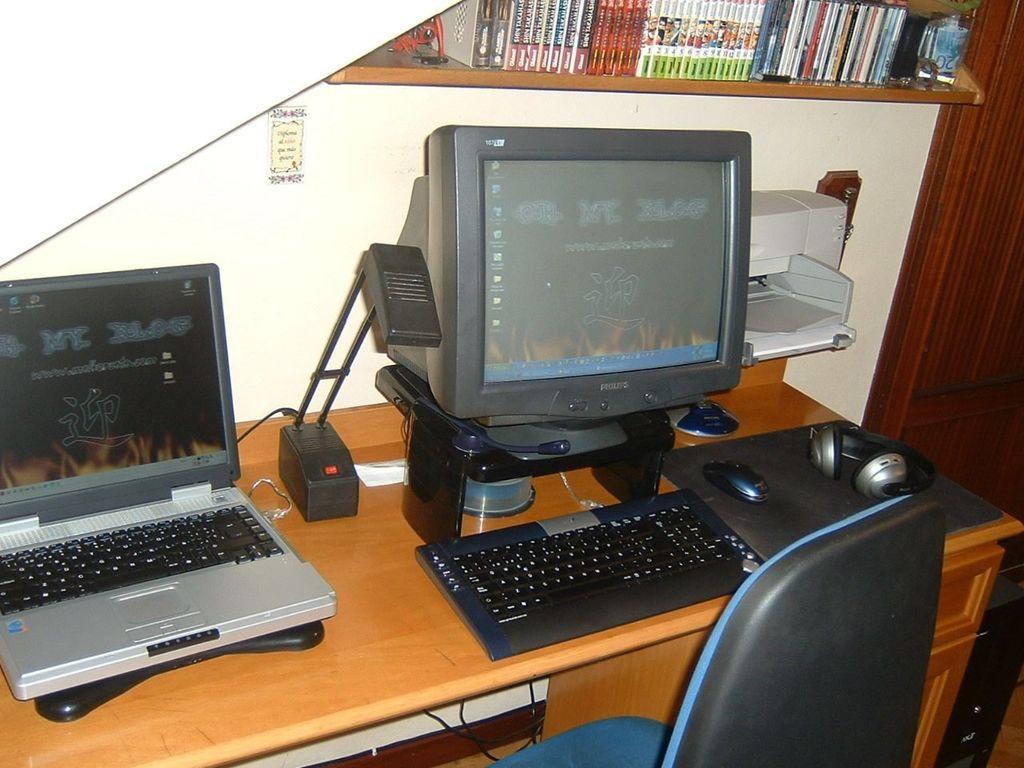Describe this image in one or two sentences. In this image there is a computer on the table and there is a laptop beside it. On the table there is lamp,headphones,mouse,cd disk on it. Beside the computer there is a printer on the top of printer there is a shelf with a books in it. There is a chair in front of it. 